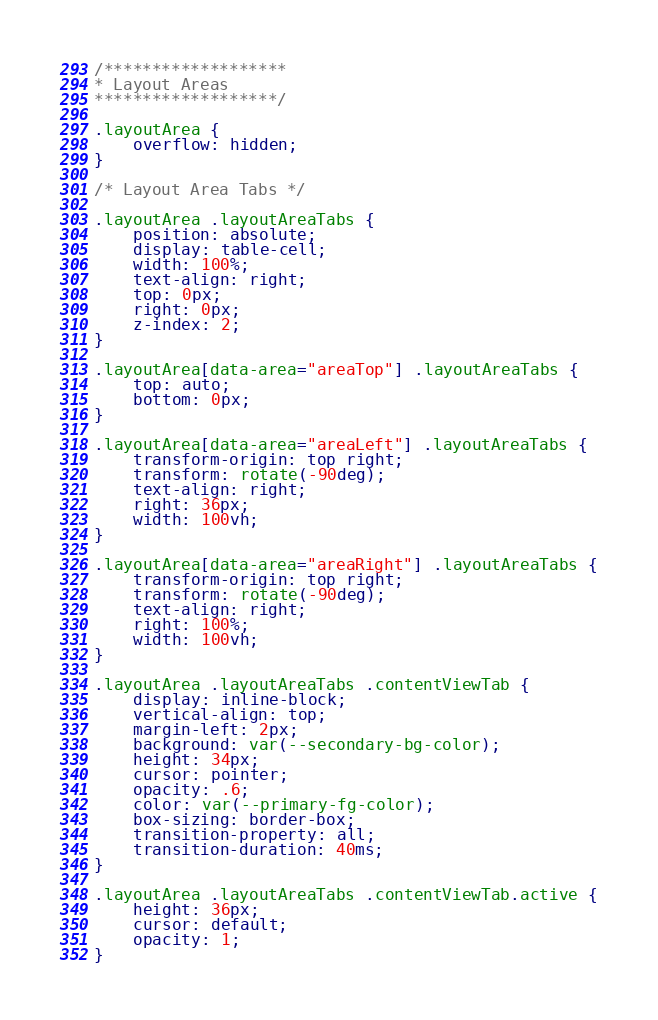<code> <loc_0><loc_0><loc_500><loc_500><_CSS_>/*******************
* Layout Areas
*******************/

.layoutArea {
    overflow: hidden;
}

/* Layout Area Tabs */

.layoutArea .layoutAreaTabs {
    position: absolute;
    display: table-cell;
    width: 100%;
    text-align: right;
    top: 0px;
    right: 0px;
    z-index: 2;
}

.layoutArea[data-area="areaTop"] .layoutAreaTabs {
    top: auto;
    bottom: 0px;
}

.layoutArea[data-area="areaLeft"] .layoutAreaTabs {
    transform-origin: top right;
    transform: rotate(-90deg);
    text-align: right;
    right: 36px;
    width: 100vh;
}

.layoutArea[data-area="areaRight"] .layoutAreaTabs {
    transform-origin: top right;
    transform: rotate(-90deg);
    text-align: right;
    right: 100%;
    width: 100vh;
}

.layoutArea .layoutAreaTabs .contentViewTab {
    display: inline-block;
    vertical-align: top;
    margin-left: 2px;
    background: var(--secondary-bg-color);
    height: 34px;
    cursor: pointer;
    opacity: .6;
    color: var(--primary-fg-color);
    box-sizing: border-box;
    transition-property: all;
    transition-duration: 40ms;
}

.layoutArea .layoutAreaTabs .contentViewTab.active {
    height: 36px;
    cursor: default;
    opacity: 1;
}
</code> 